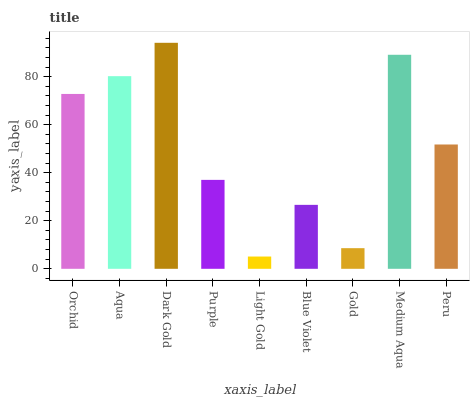Is Light Gold the minimum?
Answer yes or no. Yes. Is Dark Gold the maximum?
Answer yes or no. Yes. Is Aqua the minimum?
Answer yes or no. No. Is Aqua the maximum?
Answer yes or no. No. Is Aqua greater than Orchid?
Answer yes or no. Yes. Is Orchid less than Aqua?
Answer yes or no. Yes. Is Orchid greater than Aqua?
Answer yes or no. No. Is Aqua less than Orchid?
Answer yes or no. No. Is Peru the high median?
Answer yes or no. Yes. Is Peru the low median?
Answer yes or no. Yes. Is Aqua the high median?
Answer yes or no. No. Is Dark Gold the low median?
Answer yes or no. No. 